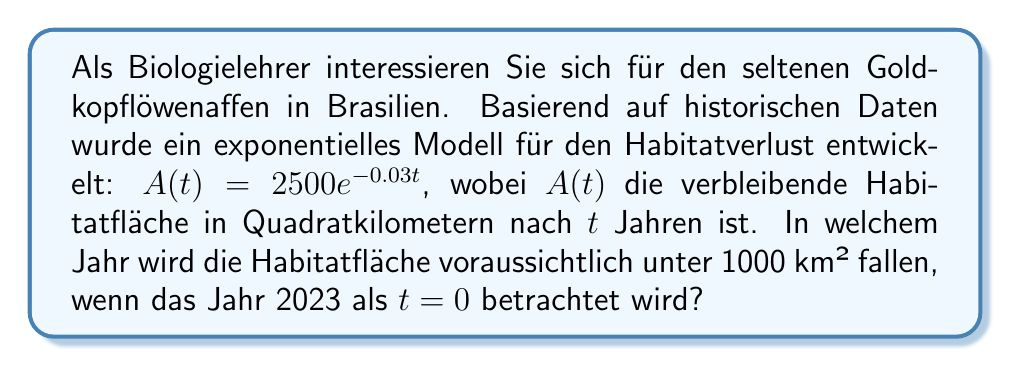Give your solution to this math problem. Um diese Frage zu beantworten, folgen wir diesen Schritten:

1) Wir suchen den Zeitpunkt $t$, an dem $A(t) < 1000$ km².

2) Setzen wir dies in unsere Gleichung ein:

   $1000 = 2500e^{-0.03t}$

3) Dividieren wir beide Seiten durch 2500:

   $\frac{1000}{2500} = e^{-0.03t}$
   $0.4 = e^{-0.03t}$

4) Nehmen wir auf beiden Seiten den natürlichen Logarithmus:

   $\ln(0.4) = \ln(e^{-0.03t})$
   $\ln(0.4) = -0.03t$

5) Lösen wir nach $t$ auf:

   $t = -\frac{\ln(0.4)}{0.03}$

6) Berechnen wir $t$:

   $t \approx 30.54$ Jahre

7) Da $t=0$ dem Jahr 2023 entspricht, addieren wir 30.54 zu 2023:

   $2023 + 30.54 \approx 2053.54$

8) Da wir nach einem ganzen Jahr fragen, runden wir auf:

   $2054$

Somit wird die Habitatfläche voraussichtlich im Jahr 2054 unter 1000 km² fallen.
Answer: 2054 